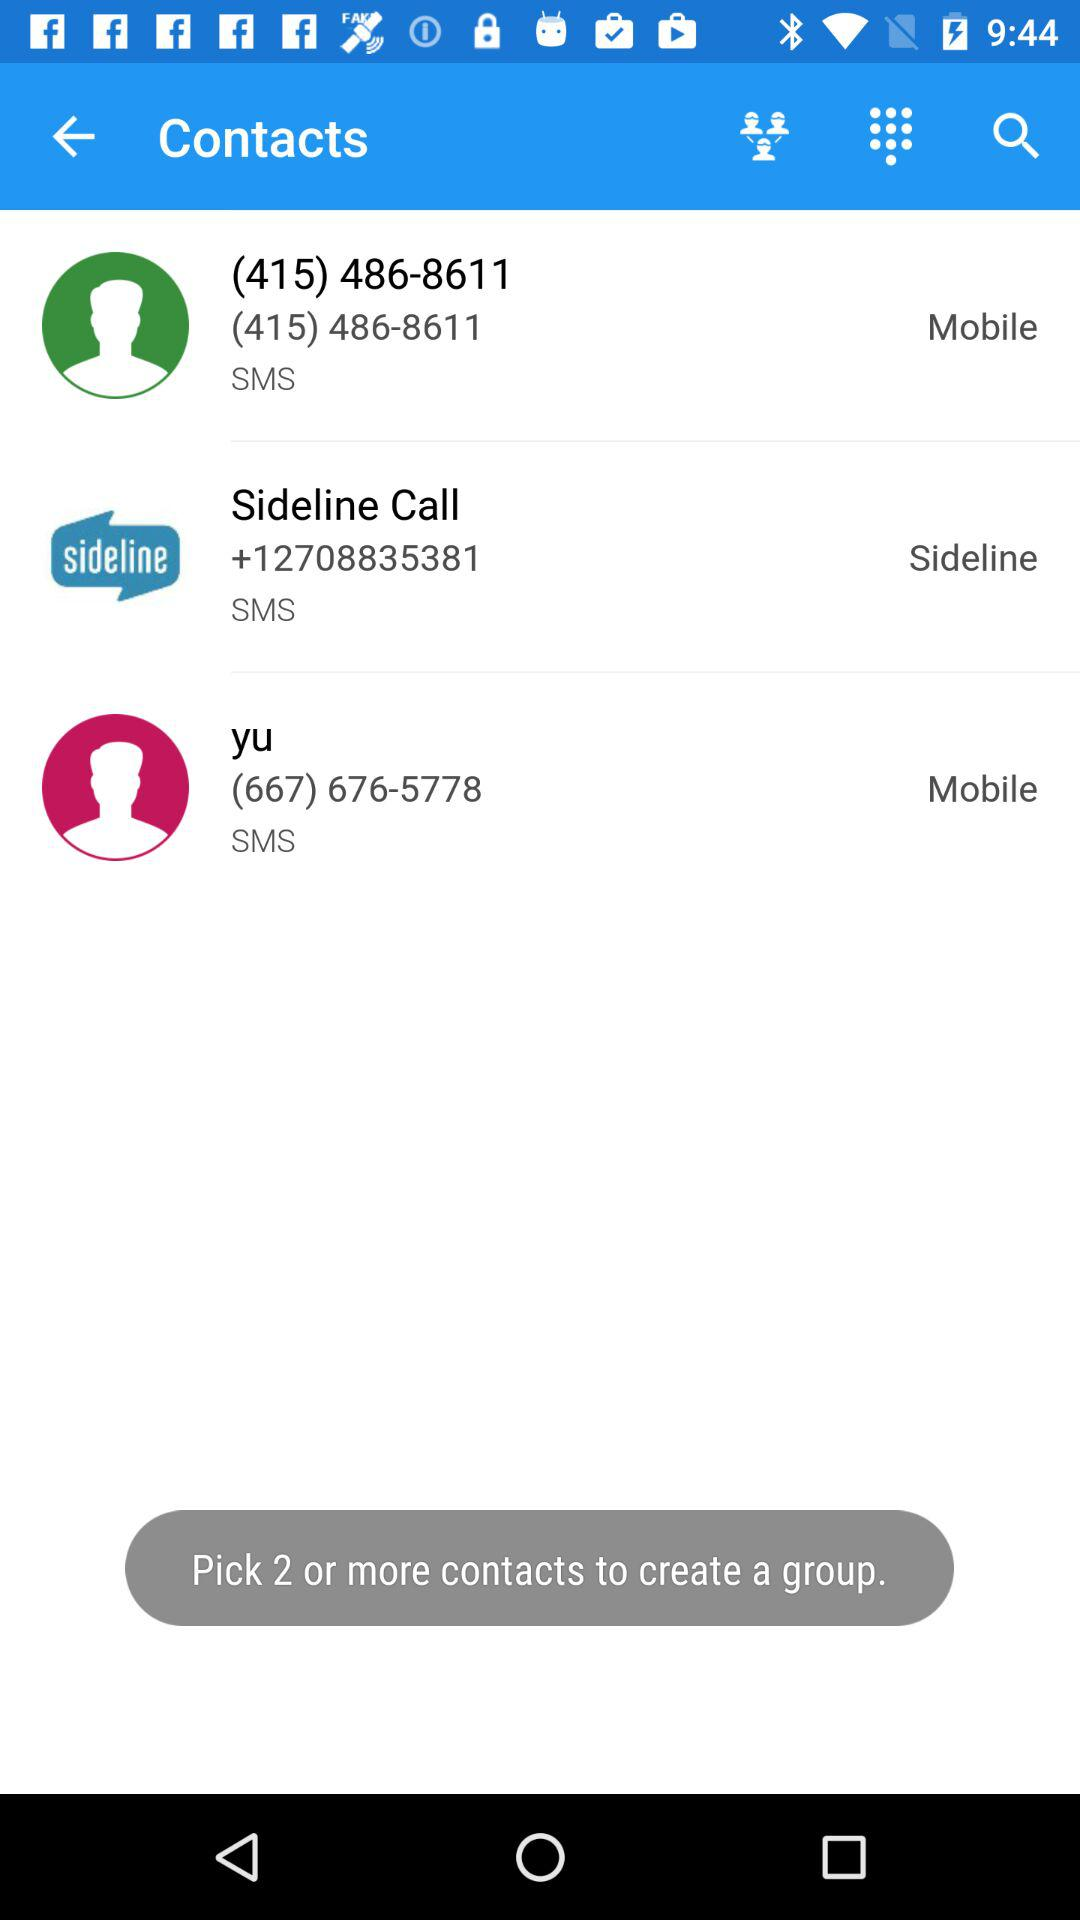How many contacts have been selected?
Answer the question using a single word or phrase. 2 